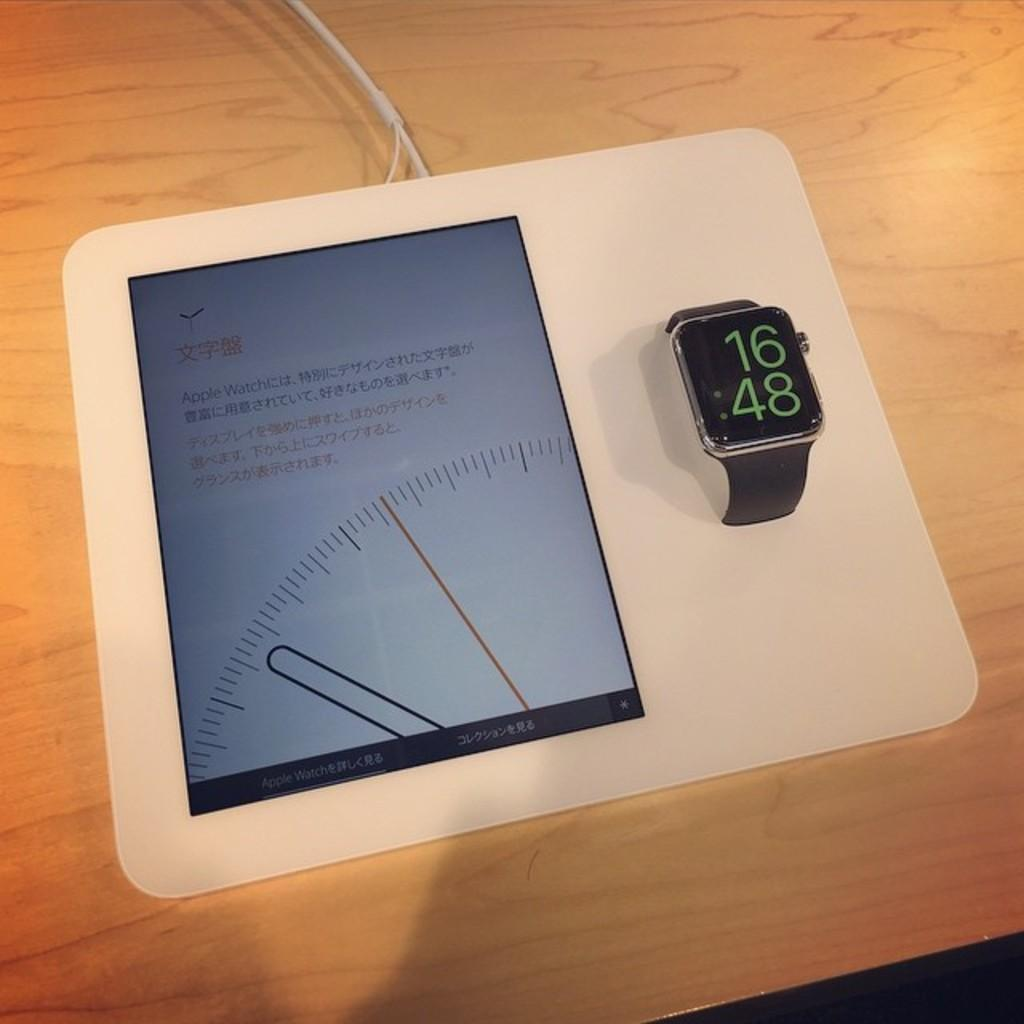<image>
Offer a succinct explanation of the picture presented. An Apple Watch displays a time of 16:48 on its dark black face. 